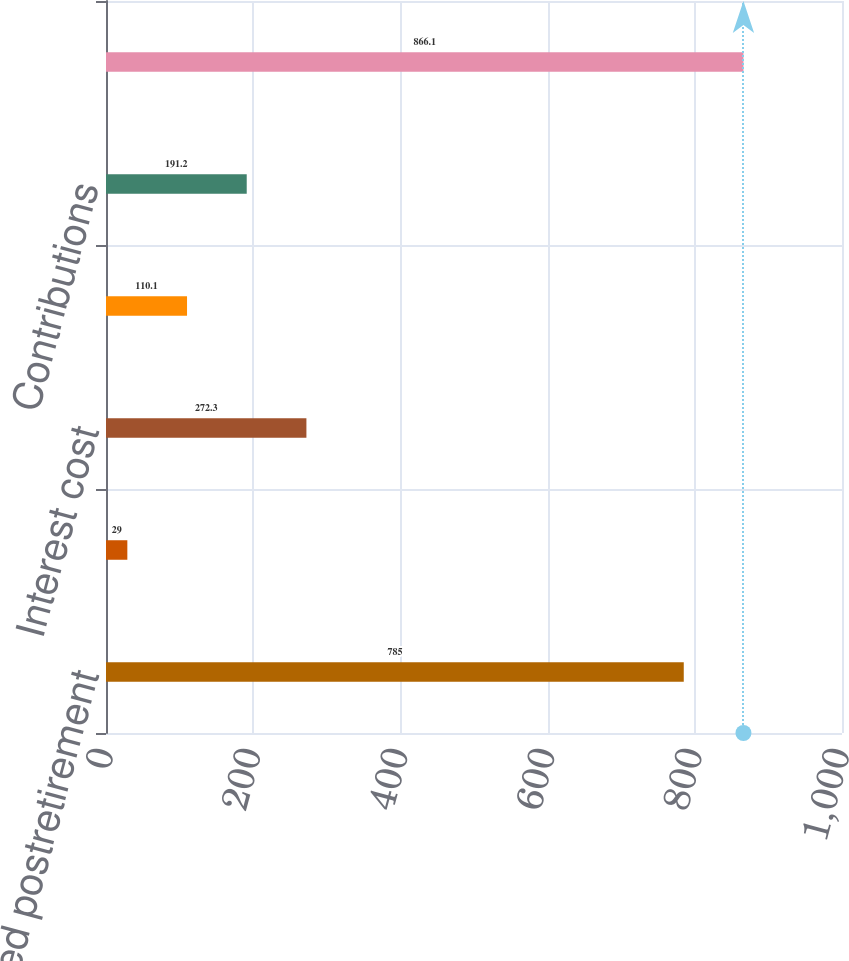<chart> <loc_0><loc_0><loc_500><loc_500><bar_chart><fcel>Accumulated postretirement<fcel>Service cost<fcel>Interest cost<fcel>Benefits paid<fcel>Contributions<fcel>Underfunded position at end of<nl><fcel>785<fcel>29<fcel>272.3<fcel>110.1<fcel>191.2<fcel>866.1<nl></chart> 